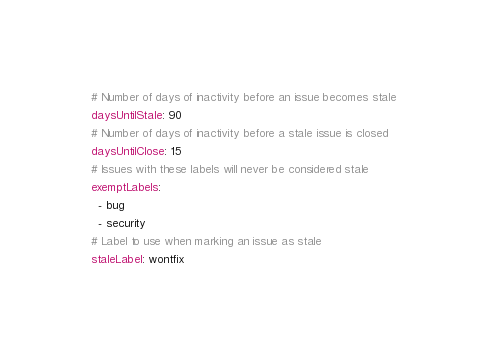<code> <loc_0><loc_0><loc_500><loc_500><_YAML_># Number of days of inactivity before an issue becomes stale
daysUntilStale: 90
# Number of days of inactivity before a stale issue is closed
daysUntilClose: 15
# Issues with these labels will never be considered stale
exemptLabels:
  - bug
  - security
# Label to use when marking an issue as stale
staleLabel: wontfix</code> 